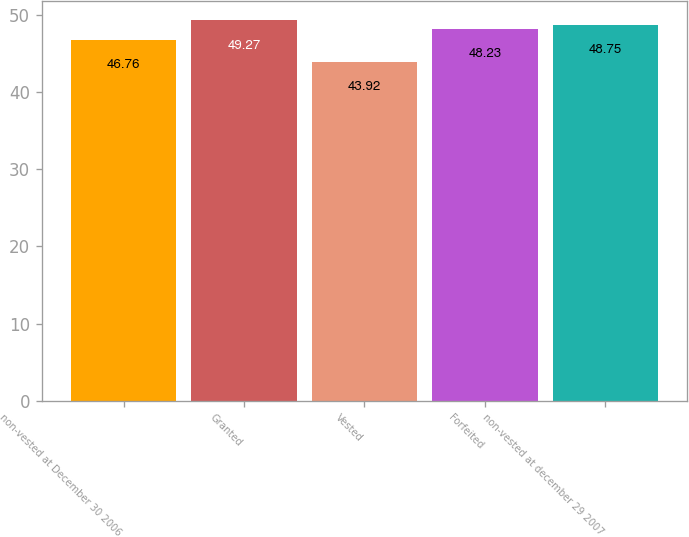<chart> <loc_0><loc_0><loc_500><loc_500><bar_chart><fcel>non-vested at December 30 2006<fcel>Granted<fcel>Vested<fcel>Forfeited<fcel>non-vested at december 29 2007<nl><fcel>46.76<fcel>49.27<fcel>43.92<fcel>48.23<fcel>48.75<nl></chart> 